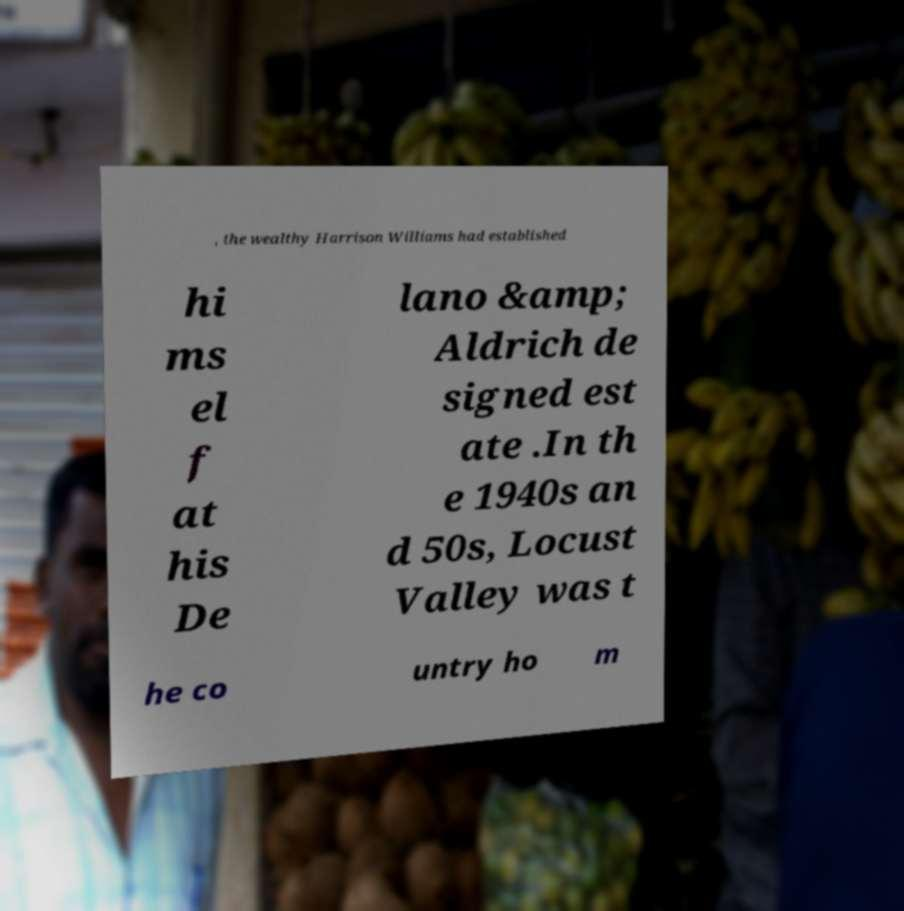I need the written content from this picture converted into text. Can you do that? , the wealthy Harrison Williams had established hi ms el f at his De lano &amp; Aldrich de signed est ate .In th e 1940s an d 50s, Locust Valley was t he co untry ho m 